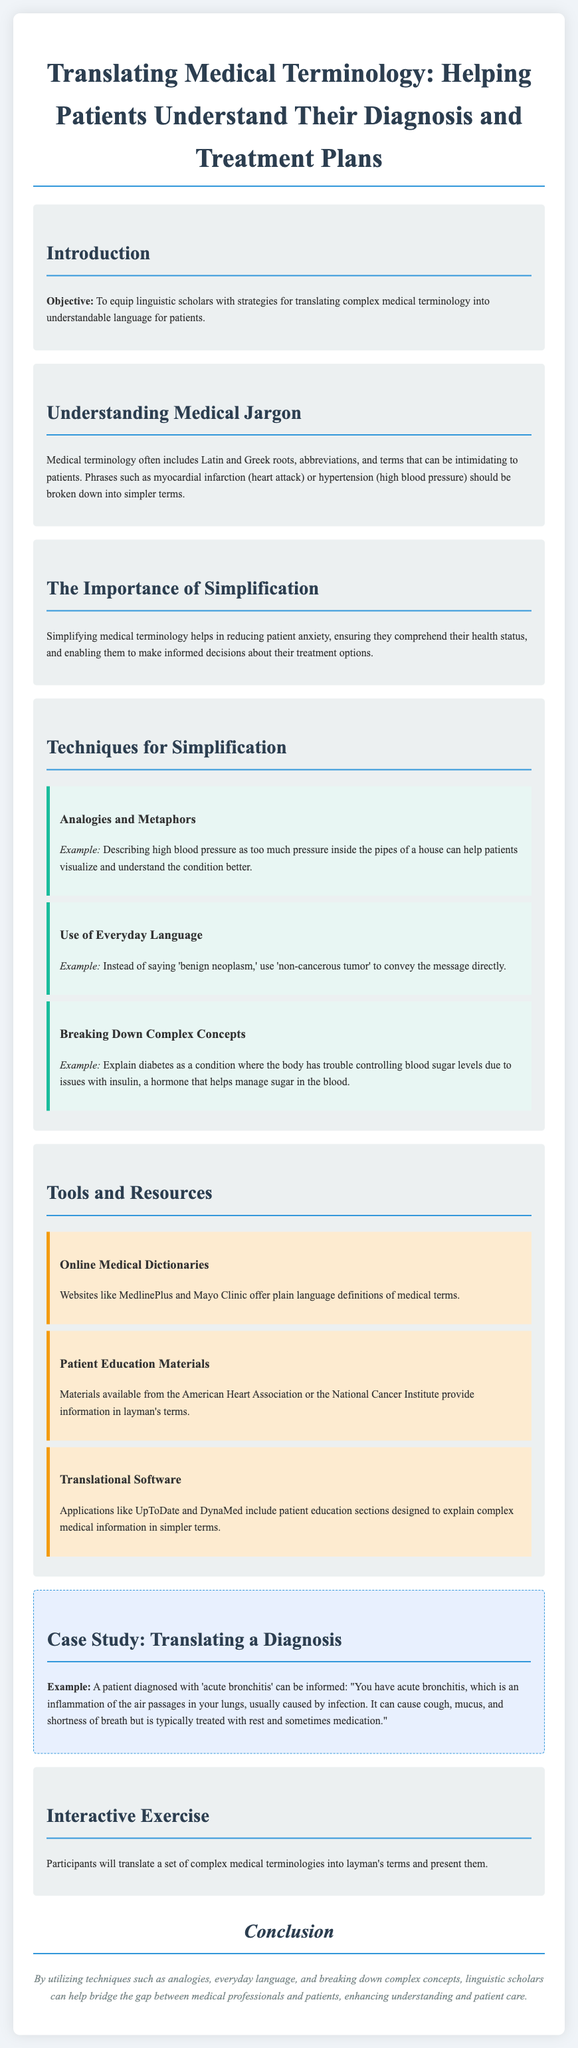What is the objective of the lesson? The objective is to equip linguistic scholars with strategies for translating complex medical terminology into understandable language for patients.
Answer: To equip linguistic scholars with strategies for translating complex medical terminology into understandable language for patients What type of jargon is often included in medical terminology? Medical terminology often includes Latin and Greek roots, abbreviations, and intimidating terms.
Answer: Latin and Greek roots, abbreviations, and intimidating terms What is an example of simplifying a medical term using everyday language? An example is using 'non-cancerous tumor' instead of 'benign neoplasm' to convey the message directly.
Answer: Non-cancerous tumor How many techniques for simplification are listed in the document? There are three techniques for simplification mentioned in the document.
Answer: Three What is one of the tools mentioned for translating medical terminology? One tool mentioned is online medical dictionaries.
Answer: Online medical dictionaries What condition is used in the case study example? The condition used in the case study example is acute bronchitis.
Answer: Acute bronchitis What will participants do in the interactive exercise? Participants will translate a set of complex medical terminologies into layman's terms and present them.
Answer: Translate complex medical terminologies into layman's terms What does the conclusion emphasize? The conclusion emphasizes the techniques that help bridge the gap between medical professionals and patients.
Answer: Techniques that help bridge the gap between medical professionals and patients 